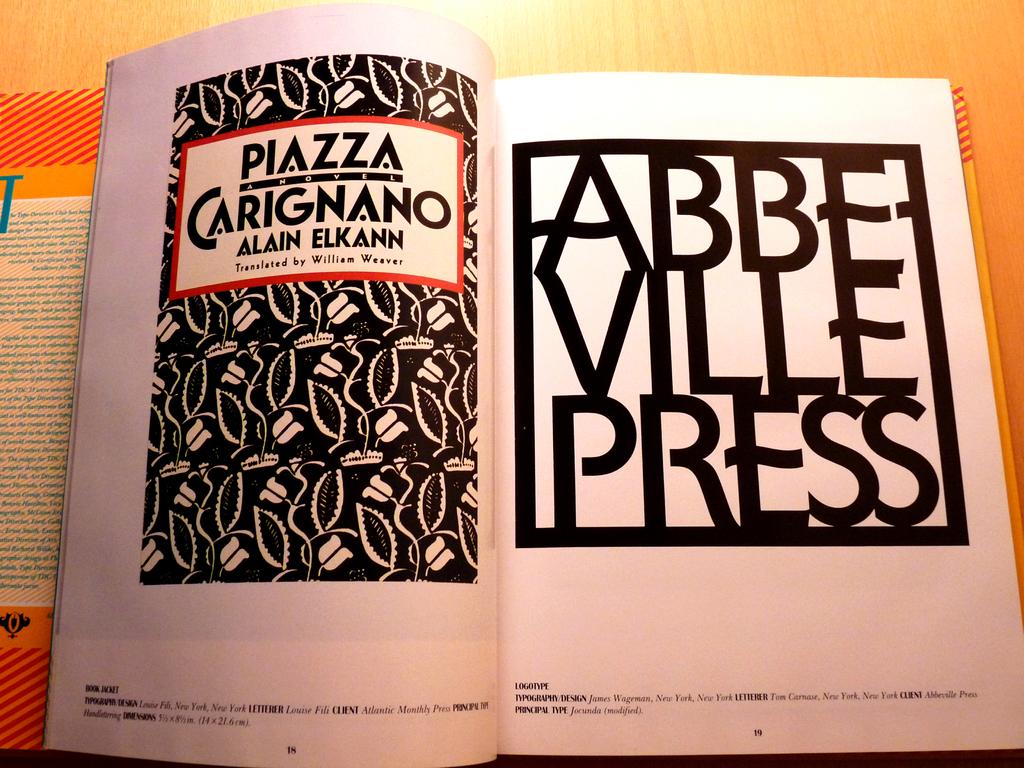What is the name of the author?
Provide a short and direct response. Alain elkann. What company published this magazine?
Provide a short and direct response. Abbeville press. 